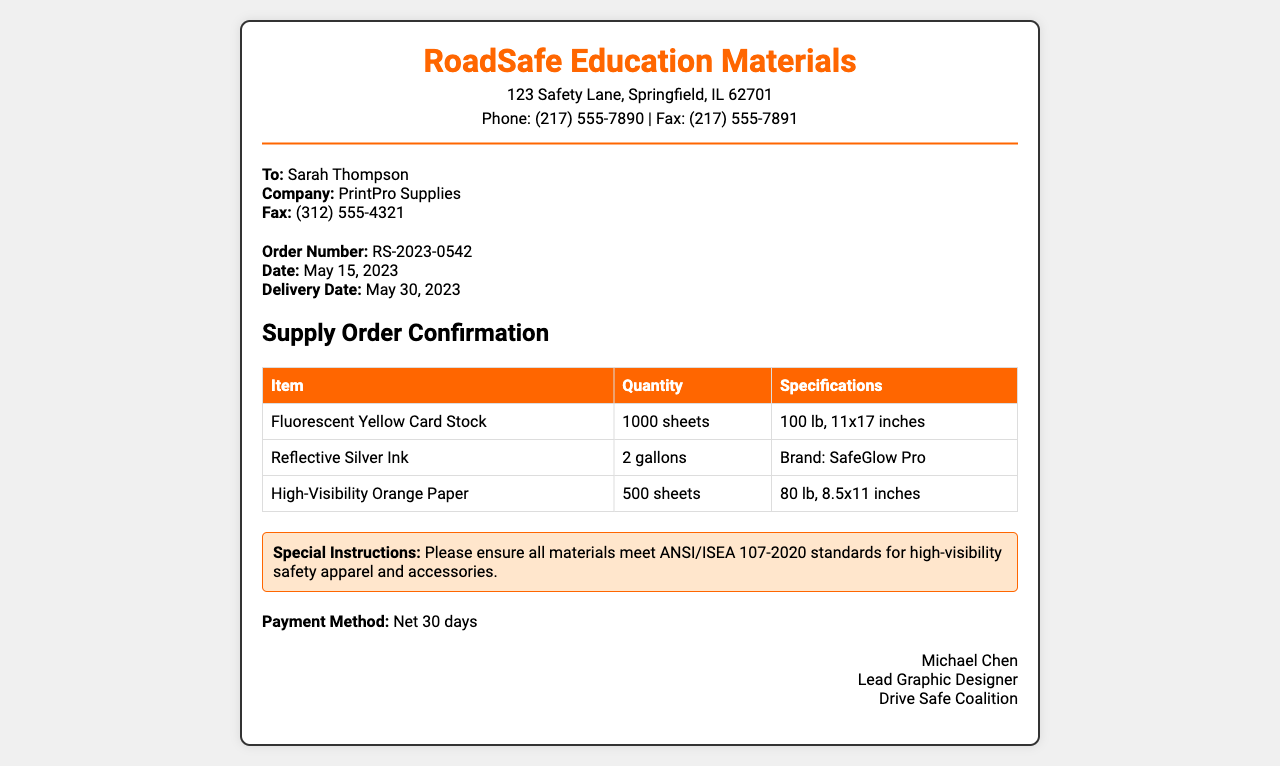What is the order number? The order number is specified in the order details section of the document as RS-2023-0542.
Answer: RS-2023-0542 Who is the recipient of the fax? The recipient's name is mentioned in the recipient section as Sarah Thompson.
Answer: Sarah Thompson What is the delivery date? The delivery date is provided in the order details section and is May 30, 2023.
Answer: May 30, 2023 How many sheets of fluorescent yellow card stock are ordered? The table lists the quantity of fluorescent yellow card stock ordered as 1000 sheets.
Answer: 1000 sheets What special instructions are provided? The document includes special instructions about materials meeting ANSI/ISEA 107-2020 standards.
Answer: ANSI/ISEA 107-2020 standards What is the payment method? The payment method is indicated in the document as Net 30 days.
Answer: Net 30 days What type of paper is ordered in the highest quantity? By comparing the quantities in the table, fluorescent yellow card stock has the highest quantity ordered.
Answer: Fluorescent Yellow Card Stock Which company is supplying the materials? The company mentioned in the recipient section is PrintPro Supplies.
Answer: PrintPro Supplies Who signed the document? The signature section identifies the signer as Michael Chen, Lead Graphic Designer.
Answer: Michael Chen 